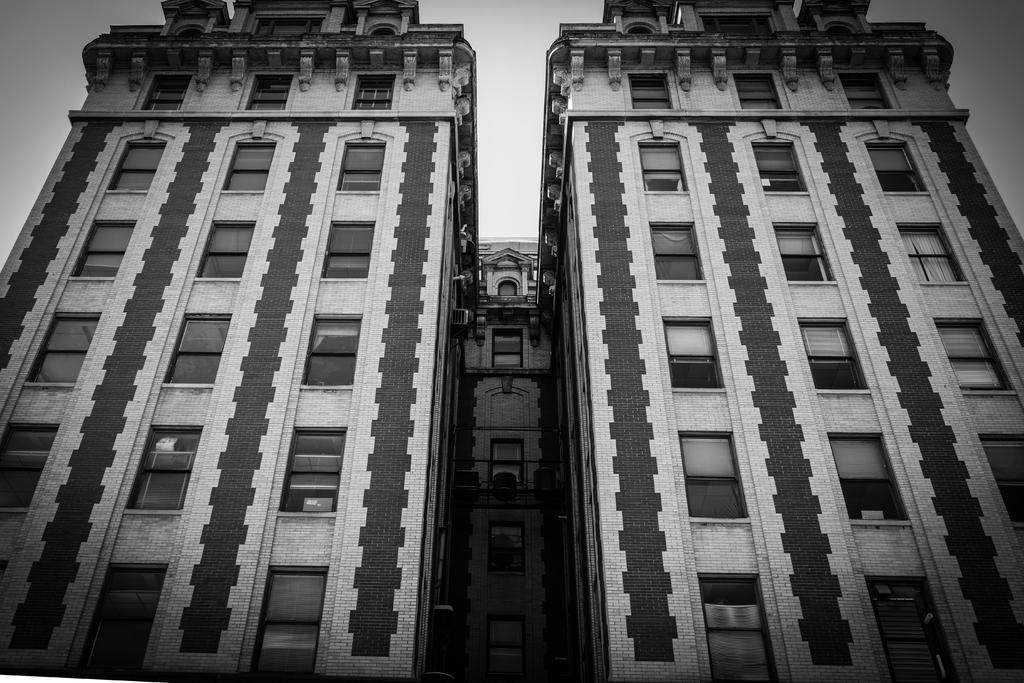What is the color scheme of the image? The image is black and white. What type of structures are present in the image? There are buildings in the image. What feature do the buildings have? The buildings have windows. What is visible at the top of the image? The sky is visible at the top of the image. What types of pets can be seen playing in the image? There are no pets visible in the image; it features black and white buildings with windows. What type of plant is growing on the roof of the building in the image? There are no plants visible on the roof of any building in the image. 